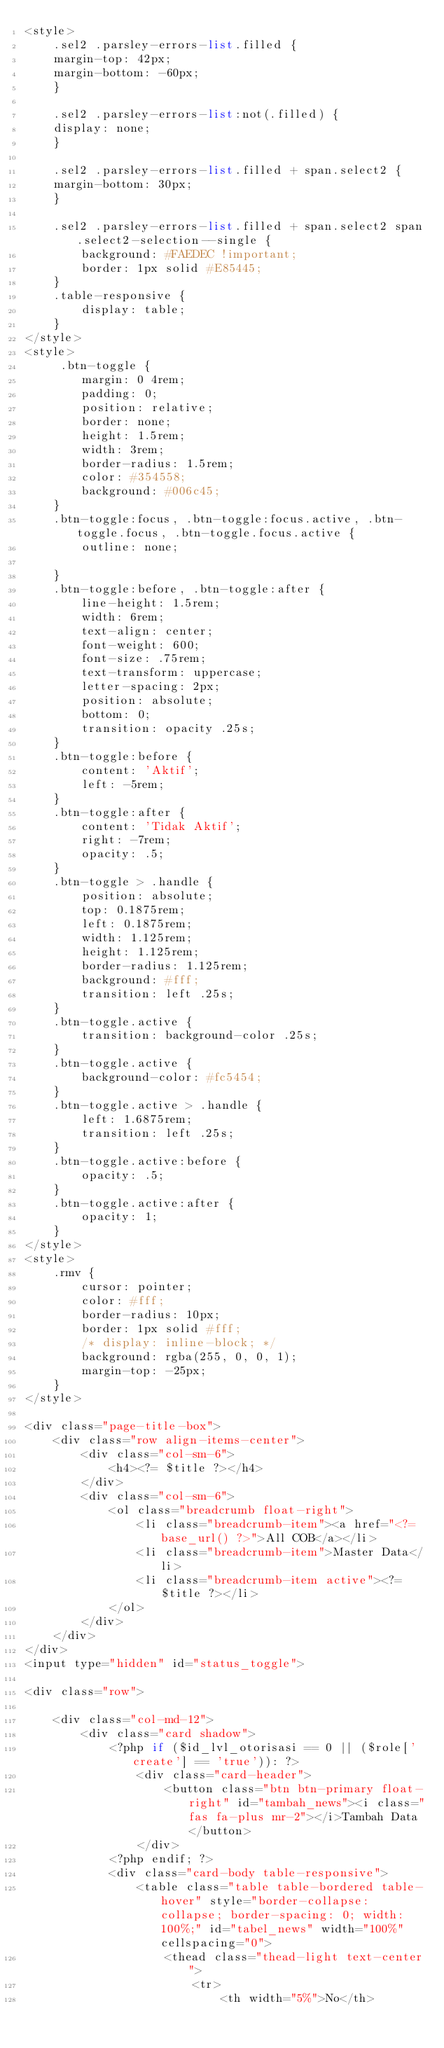<code> <loc_0><loc_0><loc_500><loc_500><_PHP_><style>
    .sel2 .parsley-errors-list.filled {
    margin-top: 42px;
    margin-bottom: -60px;
    }

    .sel2 .parsley-errors-list:not(.filled) {
    display: none;
    }

    .sel2 .parsley-errors-list.filled + span.select2 {
    margin-bottom: 30px;
    }

    .sel2 .parsley-errors-list.filled + span.select2 span.select2-selection--single {
        background: #FAEDEC !important;
        border: 1px solid #E85445;
    }
    .table-responsive {
        display: table;
    }
</style>
<style>
     .btn-toggle {
        margin: 0 4rem;
        padding: 0;
        position: relative;
        border: none;
        height: 1.5rem;
        width: 3rem;
        border-radius: 1.5rem;
        color: #354558;
        background: #006c45;
    }
    .btn-toggle:focus, .btn-toggle:focus.active, .btn-toggle.focus, .btn-toggle.focus.active {
        outline: none;
        
    }
    .btn-toggle:before, .btn-toggle:after {
        line-height: 1.5rem;
        width: 6rem;
        text-align: center;
        font-weight: 600;
        font-size: .75rem;
        text-transform: uppercase;
        letter-spacing: 2px;
        position: absolute;
        bottom: 0;
        transition: opacity .25s;
    }
    .btn-toggle:before {
        content: 'Aktif';
        left: -5rem;
    }
    .btn-toggle:after {
        content: 'Tidak Aktif';
        right: -7rem;
        opacity: .5;
    }
    .btn-toggle > .handle {
        position: absolute;
        top: 0.1875rem;
        left: 0.1875rem;
        width: 1.125rem;
        height: 1.125rem;
        border-radius: 1.125rem;
        background: #fff;
        transition: left .25s;
    }
    .btn-toggle.active {
        transition: background-color .25s;
    }
    .btn-toggle.active {
        background-color: #fc5454;
    }
    .btn-toggle.active > .handle {
        left: 1.6875rem;
        transition: left .25s;
    }
    .btn-toggle.active:before {
        opacity: .5;
    }
    .btn-toggle.active:after {
        opacity: 1;
    }
</style>
<style>
    .rmv {
        cursor: pointer;
        color: #fff;
        border-radius: 10px;
        border: 1px solid #fff;
        /* display: inline-block; */
        background: rgba(255, 0, 0, 1);
        margin-top: -25px;
    }
</style>

<div class="page-title-box">
    <div class="row align-items-center">
        <div class="col-sm-6">
            <h4><?= $title ?></h4>
        </div>
        <div class="col-sm-6">
            <ol class="breadcrumb float-right">
                <li class="breadcrumb-item"><a href="<?= base_url() ?>">All COB</a></li>
                <li class="breadcrumb-item">Master Data</li>
                <li class="breadcrumb-item active"><?= $title ?></li>
            </ol>
        </div>
    </div>
</div>
<input type="hidden" id="status_toggle">

<div class="row">

    <div class="col-md-12">
        <div class="card shadow">
            <?php if ($id_lvl_otorisasi == 0 || ($role['create'] == 'true')): ?>
                <div class="card-header">
                    <button class="btn btn-primary float-right" id="tambah_news"><i class="fas fa-plus mr-2"></i>Tambah Data</button>
                </div>
            <?php endif; ?>
            <div class="card-body table-responsive">
                <table class="table table-bordered table-hover" style="border-collapse: collapse; border-spacing: 0; width: 100%;" id="tabel_news" width="100%" cellspacing="0">
                    <thead class="thead-light text-center">
                        <tr>
                            <th width="5%">No</th></code> 